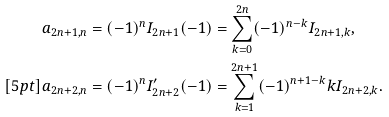Convert formula to latex. <formula><loc_0><loc_0><loc_500><loc_500>a _ { 2 n + 1 , n } & = ( - 1 ) ^ { n } I _ { 2 n + 1 } ( - 1 ) = \sum _ { k = 0 } ^ { 2 n } ( - 1 ) ^ { n - k } I _ { 2 n + 1 , k } , \\ [ 5 p t ] a _ { 2 n + 2 , n } & = ( - 1 ) ^ { n } I _ { 2 n + 2 } ^ { \prime } ( - 1 ) = \sum _ { k = 1 } ^ { 2 n + 1 } ( - 1 ) ^ { n + 1 - k } k I _ { 2 n + 2 , k } .</formula> 